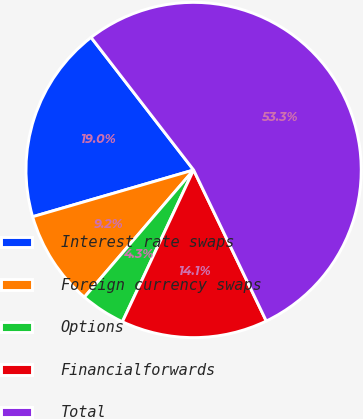Convert chart to OTSL. <chart><loc_0><loc_0><loc_500><loc_500><pie_chart><fcel>Interest rate swaps<fcel>Foreign currency swaps<fcel>Options<fcel>Financialforwards<fcel>Total<nl><fcel>19.02%<fcel>9.21%<fcel>4.31%<fcel>14.12%<fcel>53.34%<nl></chart> 